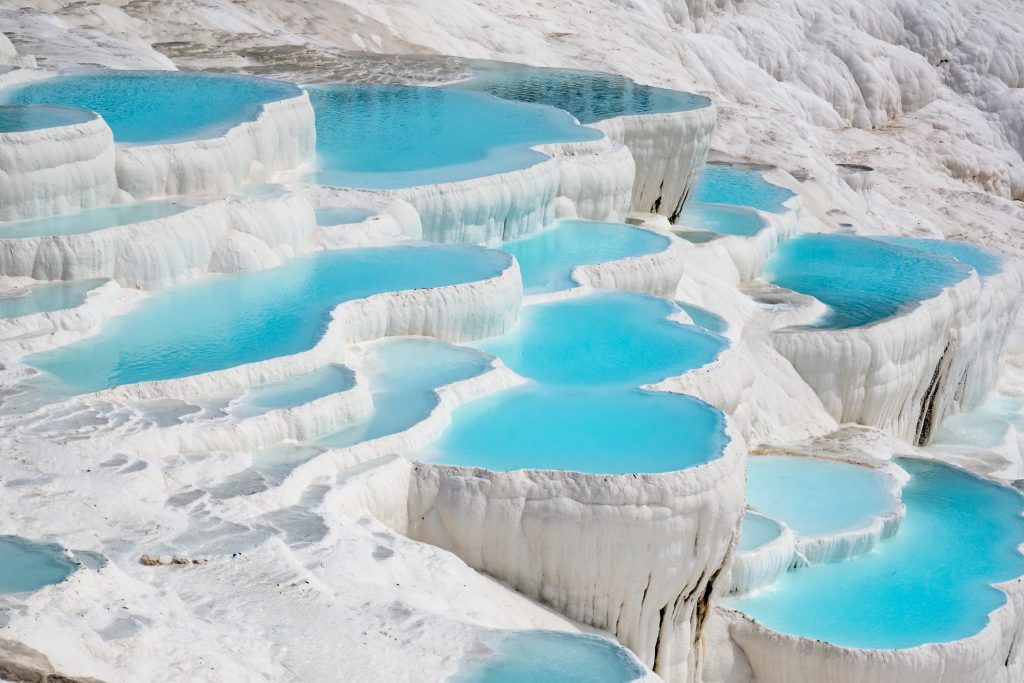Can you elaborate on the elements of the picture provided? This image captures the breathtaking vista of Pamukkale, a renowned natural marvel located in Turkey. Dominating the scene are the stunning white travertine terraces, each gracefully filled with glistening azure pools of water. These terraces are a result of mineral deposits left by flowing calcium carbonate-rich water from hot springs, creating a unique and visually striking geological formation. The perspective is aerial, akin to a bird's eye view, allowing one to fully appreciate the intricate patterns and expansive scale of this geological wonder. The terraces, reminiscent of cascading layers of soft cotton or snow, earn Pamukkale its name, meaning 'Cotton Castle' in Turkish. This image encapsulates the essence of this UNESCO World Heritage site beautifully, presenting a remarkable visual spectacle that highlights the wonders of natural processes and the striking beauty they can create. 